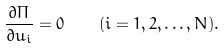Convert formula to latex. <formula><loc_0><loc_0><loc_500><loc_500>\frac { \partial \Pi } { \partial u _ { i } } = 0 \quad ( i = 1 , 2 , \dots , N ) .</formula> 